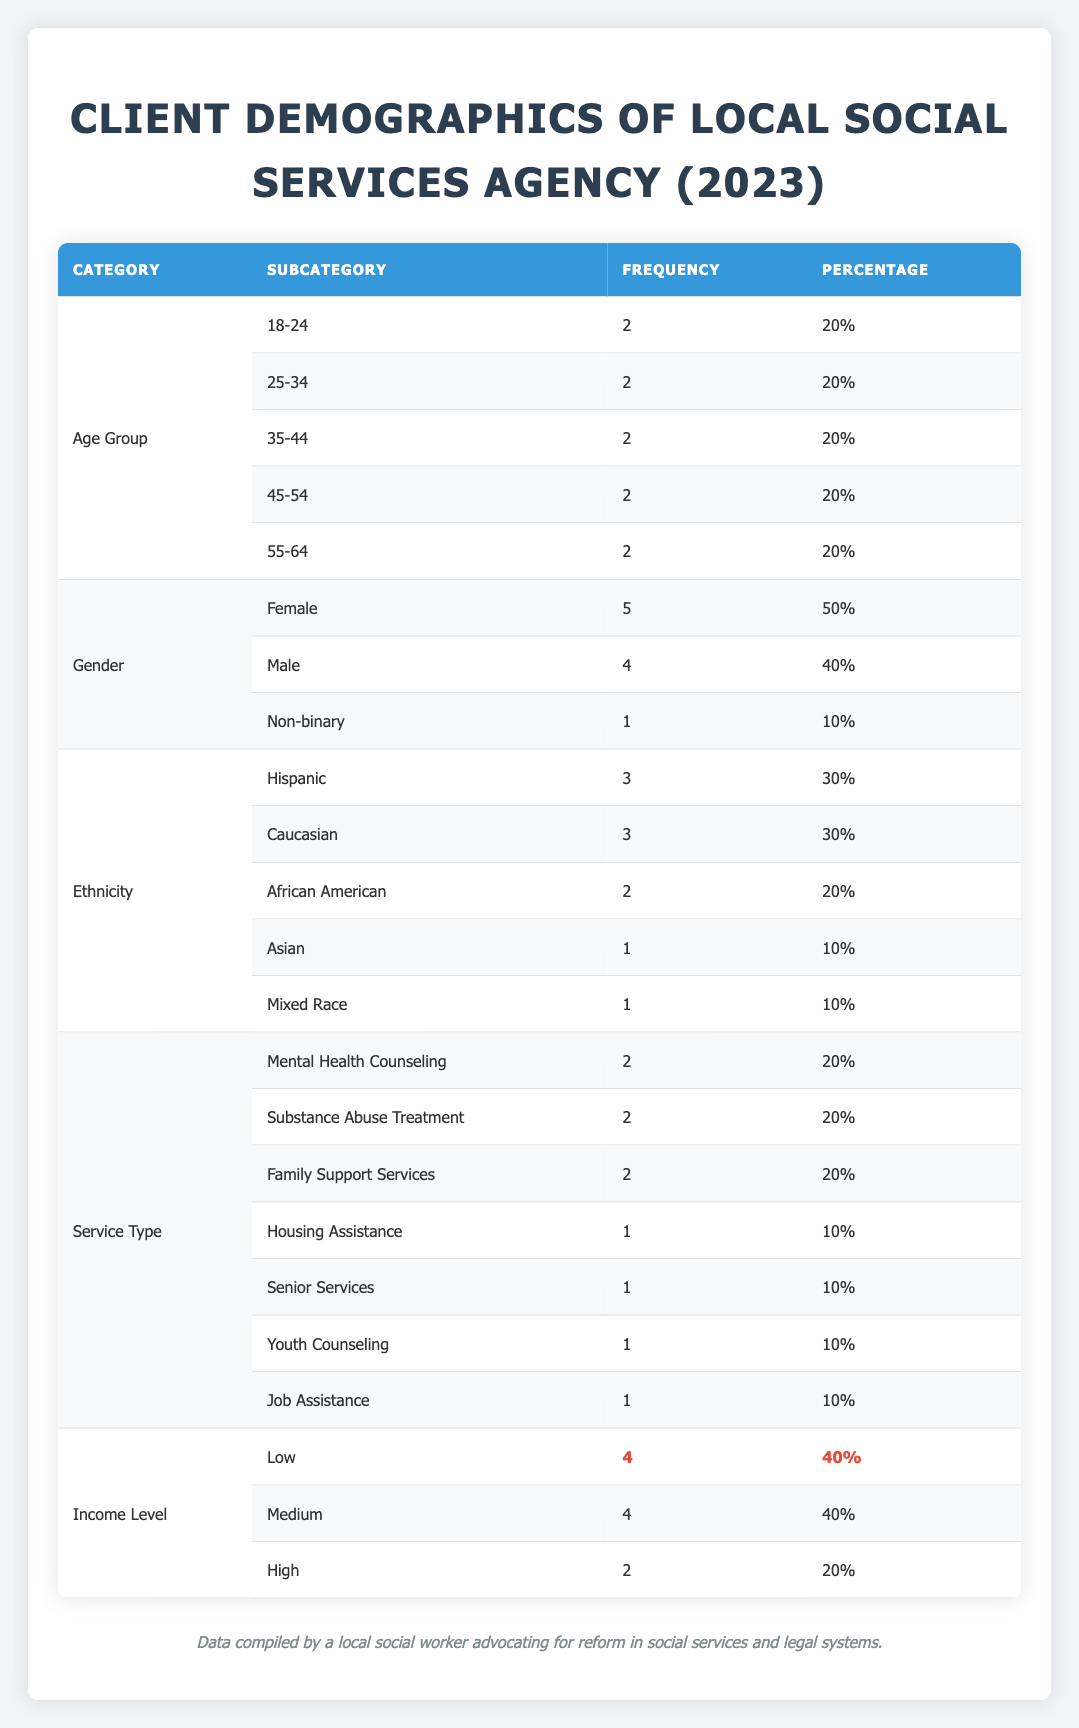What is the total number of clients served by the agency in 2023? To find the total number of clients, we add the frequencies from each age group. There are 2 (18-24) + 2 (25-34) + 2 (35-44) + 2 (45-54) + 2 (55-64) = 10 clients total.
Answer: 10 How many clients identify as Male? Looking at the Gender category, Male has a frequency of 4, indicating 4 clients identify as Male.
Answer: 4 Which Age Group has the same frequency of clients as the 45-54 age group? The 45-54 age group has a frequency of 2, and checking the other age groups, 18-24, 25-34, and 35-44 also each have a frequency of 2. So, the age groups that match are 18-24 and 35-44.
Answer: 18-24, 35-44 What percentage of clients are from low-income levels? From the Income Level section, Low has a frequency of 4 clients. We calculate the percentage as (4 / 10) * 100 = 40%.
Answer: 40% Is the number of clients receiving Housing Assistance greater than those receiving Senior Services? Housing Assistance has a frequency of 1, while Senior Services also has a frequency of 1. Since both are equal, the answer is no; they are not greater.
Answer: No What is the combined frequency of clients who are either Asian or Mixed Race? Asian has a frequency of 1 and Mixed Race has a frequency of 1. By adding these together, the total is 1 + 1 = 2.
Answer: 2 What is the average frequency of Service Types provided by the agency? There are 7 service types listed with a total frequency of (2 + 2 + 2 + 1 + 1 + 1 + 1) = 10. To find the average frequency, we divide 10 by 7, yielding approximately 1.43.
Answer: 1.43 Which ethnicities have the highest representation among clients? Both Hispanic and Caucasian have the highest frequency, each with 3 clients, making them tied for the highest representation.
Answer: Hispanic, Caucasian How many clients are receiving Mental Health Counseling or Family Support Services? Mental Health Counseling has a frequency of 2 and Family Support Services also has a frequency of 2. By adding these, we find the total: 2 + 2 = 4 clients.
Answer: 4 Which income level has the least representation? The Income Level category shows High with a frequency of 2, which is less than both Low and Medium, which have 4 each.
Answer: High 